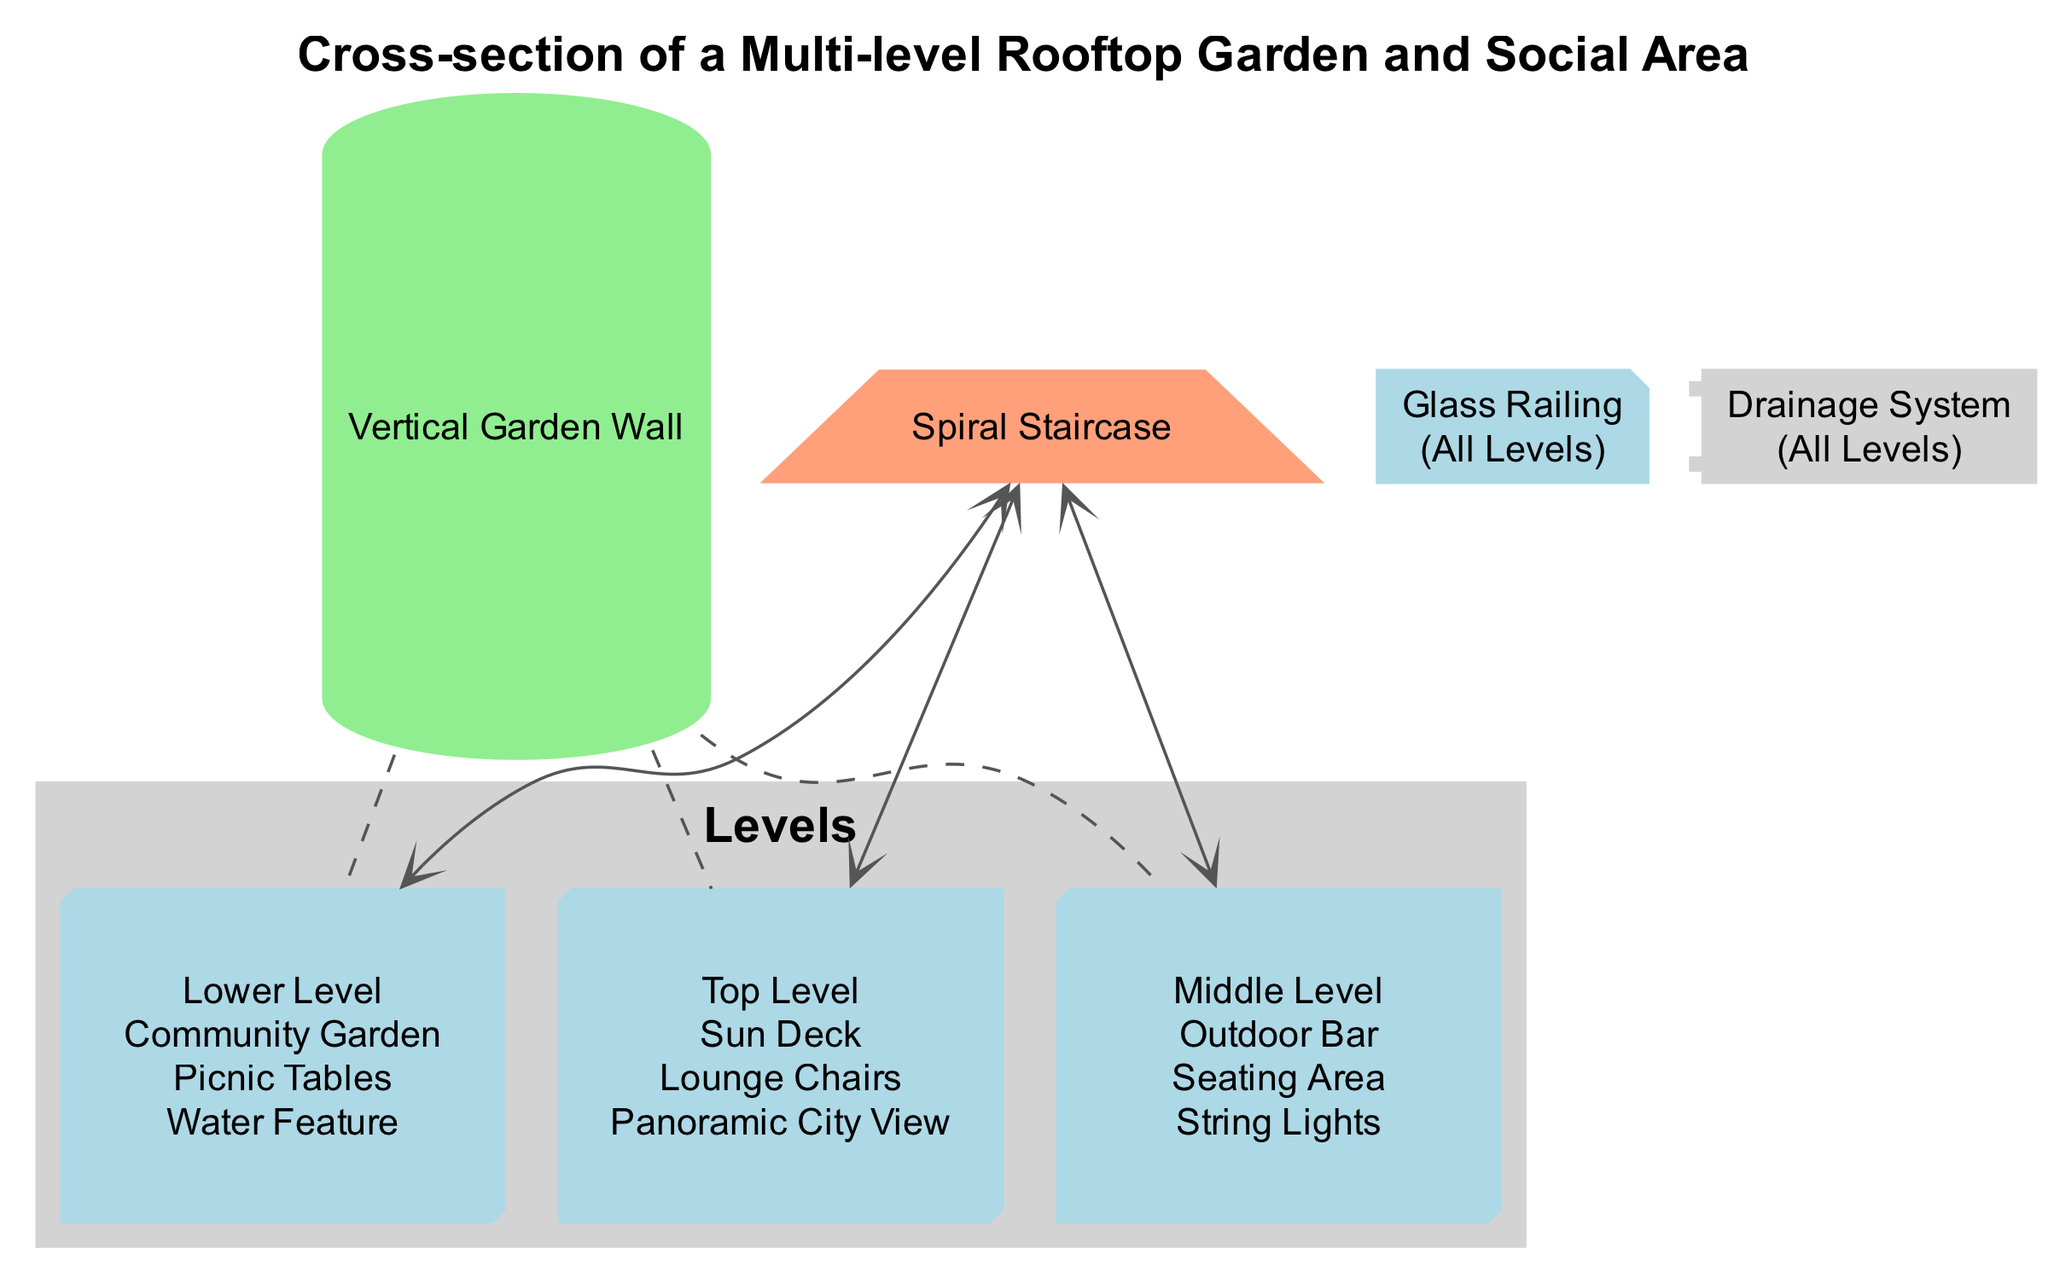What are the features of the Top Level? The Top Level features include a Sun Deck, Lounge Chairs, and a Panoramic City View. These features are listed under the corresponding level in the diagram.
Answer: Sun Deck, Lounge Chairs, Panoramic City View How many levels are there in the diagram? The diagram shows three distinct levels: Top Level, Middle Level, and Lower Level. The total number of levels can be counted from the level nodes presented in the diagram.
Answer: 3 Which level connects to the Spiral Staircase? The Spiral Staircase connects to all three levels: Top Level, Middle Level, and Lower Level. To confirm this, one can look at the connections outlined for the Staircase in the diagram.
Answer: Top Level, Middle Level, Lower Level What features are included in the Middle Level? The features in the Middle Level include an Outdoor Bar, Seating Area, and String Lights. These features can be identified from the node representing the Middle Level in the diagram.
Answer: Outdoor Bar, Seating Area, String Lights What is positioned at the Lower Level? The Lower Level features a Community Garden, Picnic Tables, and a Water Feature, which can be read directly from the level information in the diagram.
Answer: Community Garden, Picnic Tables, Water Feature What structural element connects all three levels? The Vertical Garden Wall is the structural element that connects all three levels, as indicated by its connections shown in the diagram.
Answer: Vertical Garden Wall How many features are found in total across all levels? There are a total of 9 features when you count the features from each level: 3 from Top, 3 from Middle, and 3 from Lower Levels (3+3+3=9). The total can be computed by adding the listed features under each level.
Answer: 9 Which feature is present on all levels? The Glass Railing is present on all levels, as specified in the diagram. This is indicated by its note in the diagram stating it applies to "All Levels."
Answer: Glass Railing What is the purpose of the Drainage System? The Drainage System is a utility located on all levels, designed to manage water flow, although the specific explanation is not visually detailed in the diagram. Its function is inferred from the context of its presence on all levels.
Answer: Manage water flow 